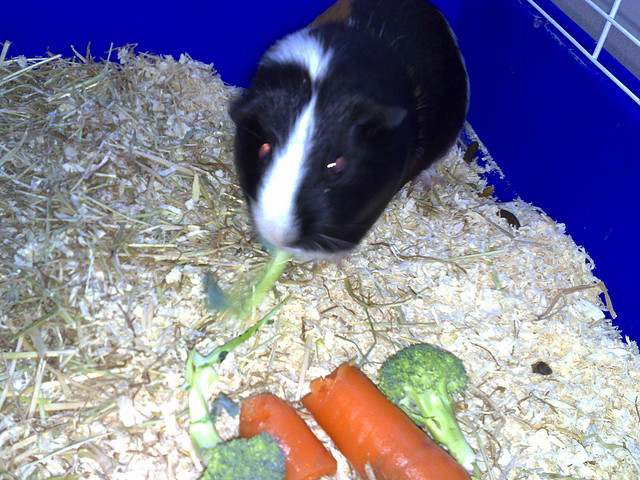What is the animal in the picture doing? The guinea pig in the image is enjoying a meal. It looks like it's currently nibbling on a piece of broccoli. 